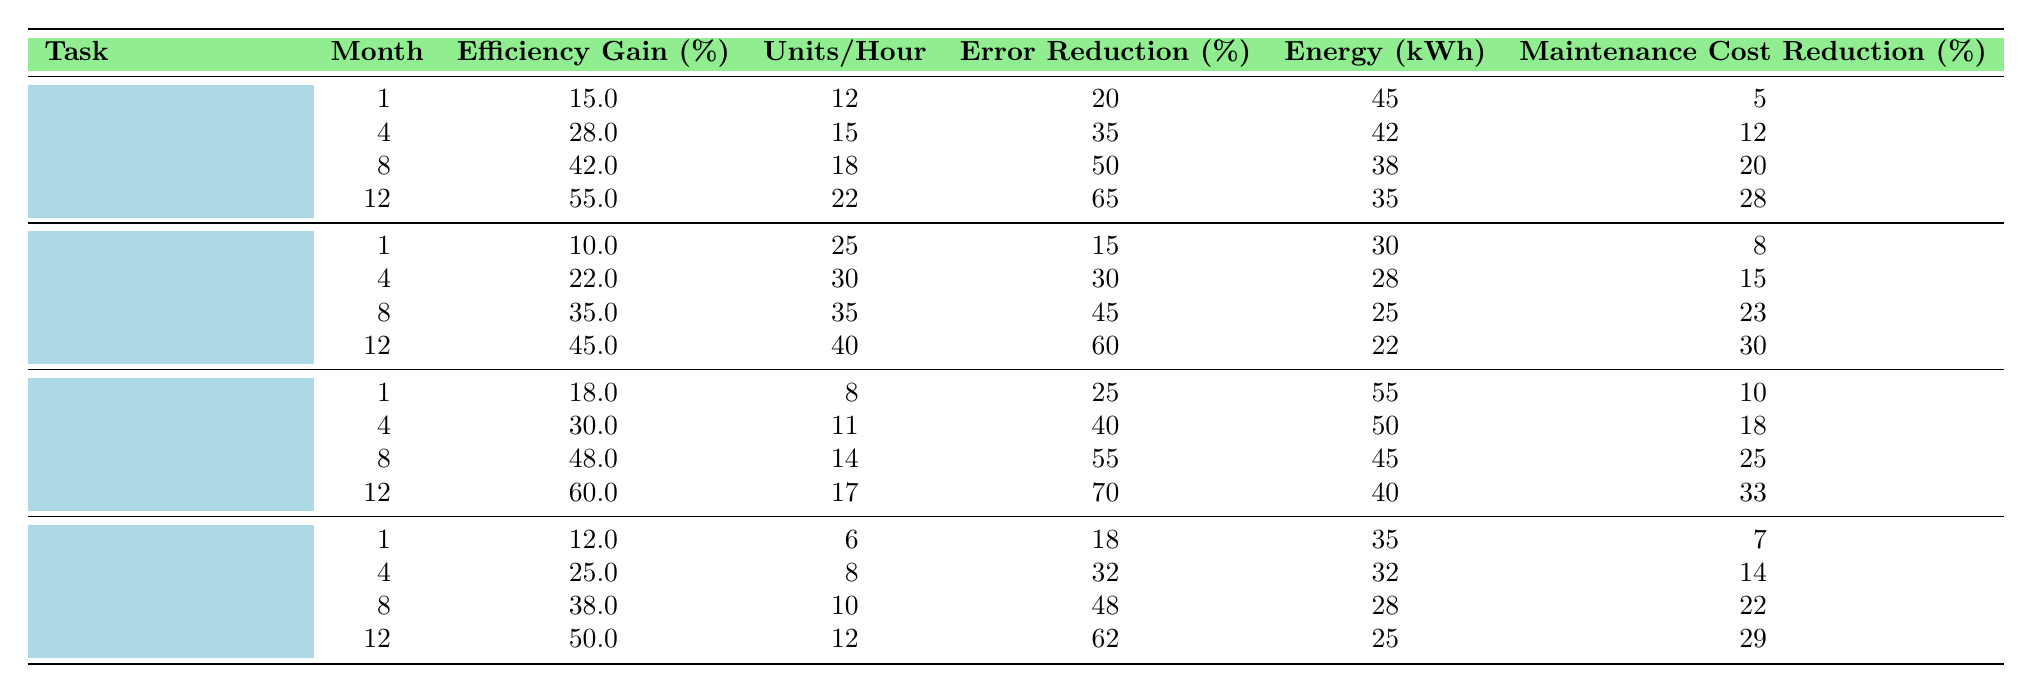What is the maximum efficiency gain percentage for CNC routing tasks? Looking at the CNC routing row, the efficiency gains are 15%, 28%, 42%, and 55% across the months. The maximum value here is 55%.
Answer: 55% Which task shows the greatest increase in units produced per hour from month 1 to month 12? For each task, calculate the difference in units produced per hour between month 1 and month 12. CNC routing increases from 12 to 22 (10 units), automated sanding from 25 to 40 (15 units), robotic painting from 8 to 17 (9 units), and automated assembly from 6 to 12 (6 units). Automated sanding has the greatest increase of 15 units.
Answer: Automated sanding What is the average error rate reduction for robotic painting over the 12 months? Sum the error rate reductions for robotic painting: 25, 40, 55, and 70, which equals 190. Divide by 4 (the number of data points): 190 / 4 = 47.5.
Answer: 47.5 True or False: The energy consumption decreases for every task from month 1 to month 12. By examining the energy consumption values for each task across all months, CNC routing shows a decrease, automated sanding decreases, robotic painting decreases, and automated assembly also decreases. Therefore, this statement is true.
Answer: True What is the total reduction in maintenance costs for automated assembly from month 1 to month 12? The maintenance costs for automated assembly are 7%, 14%, 22%, and 29%. Subtract the initial cost from the final cost: 29 - 7 = 22%.
Answer: 22% Which task has the highest efficiency gain after 12 months? The efficiency gain at month 12 for all tasks is 55% (CNC routing), 45% (automated sanding), 60% (robotic painting), and 50% (automated assembly). Thus, robotic painting has the highest gain at 60%.
Answer: Robotic painting What is the overall average energy consumption across all tasks in month 12? For month 12, the energy consumption is 35 (CNC routing), 22 (automated sanding), 40 (robotic painting), and 25 (automated assembly). The sum is 122; dividing by 4 gives an average of 30.5.
Answer: 30.5 Which task has the largest error reduction percentage in month 8? The error reductions for month 8 are 50% for CNC routing, 45% for automated sanding, 55% for robotic painting, and 48% for automated assembly. The largest value is 55% for robotic painting.
Answer: Robotic painting If a workshop aims for at least a 50% efficiency gain, which tasks achieved this by month 12? By month 12, CNC routing has 55%, automated sanding has 45%, robotic painting has 60%, and automated assembly has 50%. The tasks that achieved at least 50% efficiency gain are CNC routing, robotic painting, and automated assembly.
Answer: CNC routing, robotic painting, automated assembly How much did maintenance costs reduce for automated sanding from month 1 to month 12? The costs for automated sanding are 8% in month 1 and 30% in month 12. The reduction is 30 - 8 = 22%.
Answer: 22% 